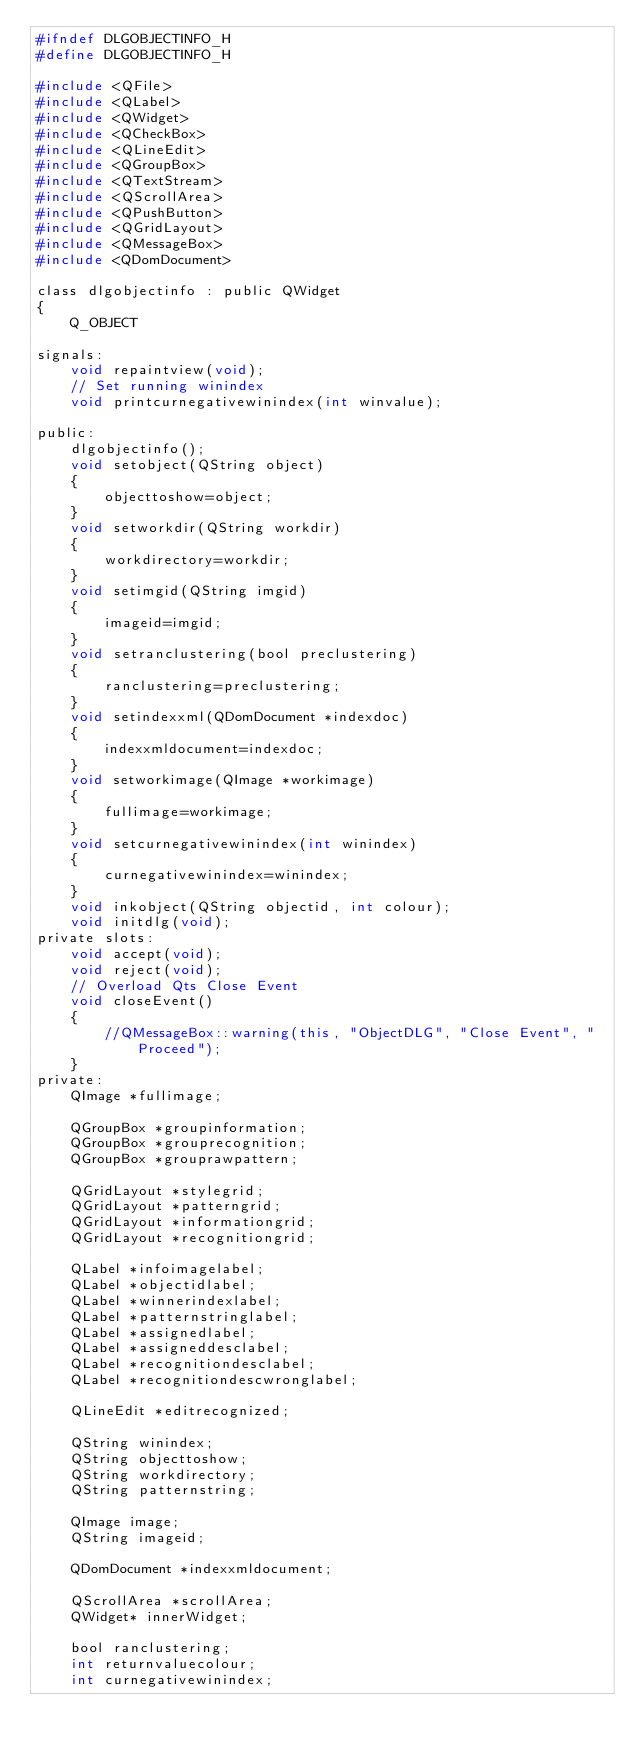Convert code to text. <code><loc_0><loc_0><loc_500><loc_500><_C_>#ifndef DLGOBJECTINFO_H
#define DLGOBJECTINFO_H

#include <QFile>
#include <QLabel>
#include <QWidget>
#include <QCheckBox>
#include <QLineEdit>
#include <QGroupBox>
#include <QTextStream>
#include <QScrollArea>
#include <QPushButton>
#include <QGridLayout>
#include <QMessageBox>
#include <QDomDocument>

class dlgobjectinfo : public QWidget
{
	Q_OBJECT

signals:
	void repaintview(void);
	// Set running winindex
	void printcurnegativewinindex(int winvalue);

public:
	dlgobjectinfo();
	void setobject(QString object)
	{
		objecttoshow=object;
	}
	void setworkdir(QString workdir)
	{
		workdirectory=workdir;
	}
	void setimgid(QString imgid)
	{
		imageid=imgid;
	}
	void setranclustering(bool preclustering)
	{
		ranclustering=preclustering;
	}
	void setindexxml(QDomDocument *indexdoc)
	{
		indexxmldocument=indexdoc;
	}
	void setworkimage(QImage *workimage)
	{
		fullimage=workimage;
	}
	void setcurnegativewinindex(int winindex)
	{
		curnegativewinindex=winindex;
	}
	void inkobject(QString objectid, int colour);
	void initdlg(void);
private slots:
	void accept(void);
	void reject(void);
	// Overload Qts Close Event
	void closeEvent()
	{
		//QMessageBox::warning(this, "ObjectDLG", "Close Event", "Proceed");
	}
private:
	QImage *fullimage;

	QGroupBox *groupinformation;
	QGroupBox *grouprecognition;
	QGroupBox *grouprawpattern;

	QGridLayout *stylegrid;
	QGridLayout *patterngrid;
	QGridLayout *informationgrid;
	QGridLayout *recognitiongrid;

	QLabel *infoimagelabel;
	QLabel *objectidlabel;
	QLabel *winnerindexlabel;
	QLabel *patternstringlabel;
	QLabel *assignedlabel;
	QLabel *assigneddesclabel;
	QLabel *recognitiondesclabel;
	QLabel *recognitiondescwronglabel;

	QLineEdit *editrecognized;

	QString winindex;
	QString objecttoshow;
	QString workdirectory;
	QString patternstring;

	QImage image;
	QString imageid;

	QDomDocument *indexxmldocument;

	QScrollArea *scrollArea;
	QWidget* innerWidget;

	bool ranclustering;
	int returnvaluecolour;
	int curnegativewinindex;</code> 